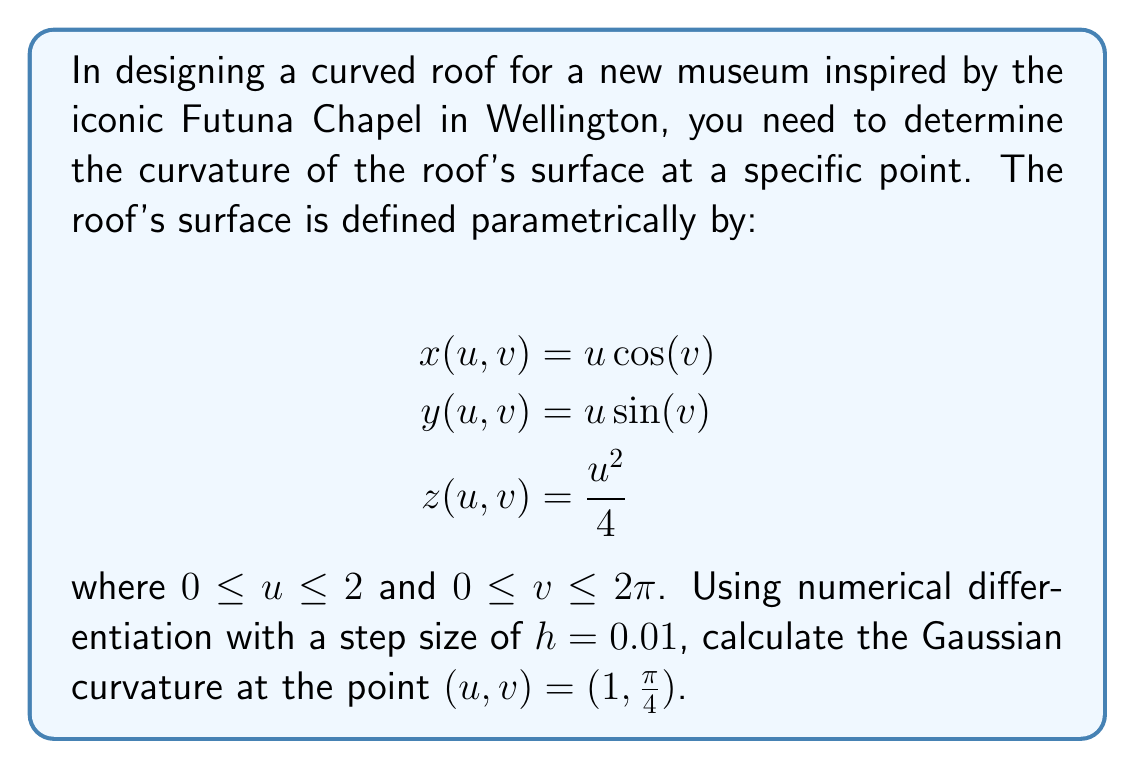Can you solve this math problem? To calculate the Gaussian curvature of a parametric surface, we need to compute the coefficients of the first and second fundamental forms. Let's break this down step-by-step:

1) First, we need to compute the partial derivatives $\mathbf{r}_u$, $\mathbf{r}_v$, $\mathbf{r}_{uu}$, $\mathbf{r}_{uv}$, and $\mathbf{r}_{vv}$ using central difference formulas:

   $\mathbf{r}_u \approx \frac{\mathbf{r}(u+h,v) - \mathbf{r}(u-h,v)}{2h}$
   $\mathbf{r}_v \approx \frac{\mathbf{r}(u,v+h) - \mathbf{r}(u,v-h)}{2h}$
   $\mathbf{r}_{uu} \approx \frac{\mathbf{r}(u+h,v) - 2\mathbf{r}(u,v) + \mathbf{r}(u-h,v)}{h^2}$
   $\mathbf{r}_{vv} \approx \frac{\mathbf{r}(u,v+h) - 2\mathbf{r}(u,v) + \mathbf{r}(u,v-h)}{h^2}$
   $\mathbf{r}_{uv} \approx \frac{\mathbf{r}(u+h,v+h) - \mathbf{r}(u+h,v-h) - \mathbf{r}(u-h,v+h) + \mathbf{r}(u-h,v-h)}{4h^2}$

2) Calculate these values at $(u,v) = (1,\frac{\pi}{4})$ with $h=0.01$:

   $\mathbf{r}_u \approx (0.7071, 0.7071, 0.5000)$
   $\mathbf{r}_v \approx (-0.7071, 0.7071, 0)$
   $\mathbf{r}_{uu} \approx (0, 0, 0.5000)$
   $\mathbf{r}_{vv} \approx (-1.0000, -1.0000, 0)$
   $\mathbf{r}_{uv} \approx (-0.7071, 0.7071, 0)$

3) Compute the coefficients of the first fundamental form:
   $E = \mathbf{r}_u \cdot \mathbf{r}_u \approx 1.2500$
   $F = \mathbf{r}_u \cdot \mathbf{r}_v \approx 0$
   $G = \mathbf{r}_v \cdot \mathbf{r}_v \approx 1.0000$

4) Compute the unit normal vector:
   $\mathbf{N} = \frac{\mathbf{r}_u \times \mathbf{r}_v}{|\mathbf{r}_u \times \mathbf{r}_v|} \approx (-0.4472, -0.4472, 0.7746)$

5) Compute the coefficients of the second fundamental form:
   $L = \mathbf{r}_{uu} \cdot \mathbf{N} \approx 0.3873$
   $M = \mathbf{r}_{uv} \cdot \mathbf{N} \approx 0$
   $N = \mathbf{r}_{vv} \cdot \mathbf{N} \approx 0.8944$

6) Calculate the Gaussian curvature:
   $K = \frac{LN - M^2}{EG - F^2} \approx \frac{0.3873 \cdot 0.8944 - 0^2}{1.2500 \cdot 1.0000 - 0^2} \approx 0.2769$

Therefore, the Gaussian curvature at the point $(u,v) = (1,\frac{\pi}{4})$ is approximately 0.2769.
Answer: $K \approx 0.2769$ 